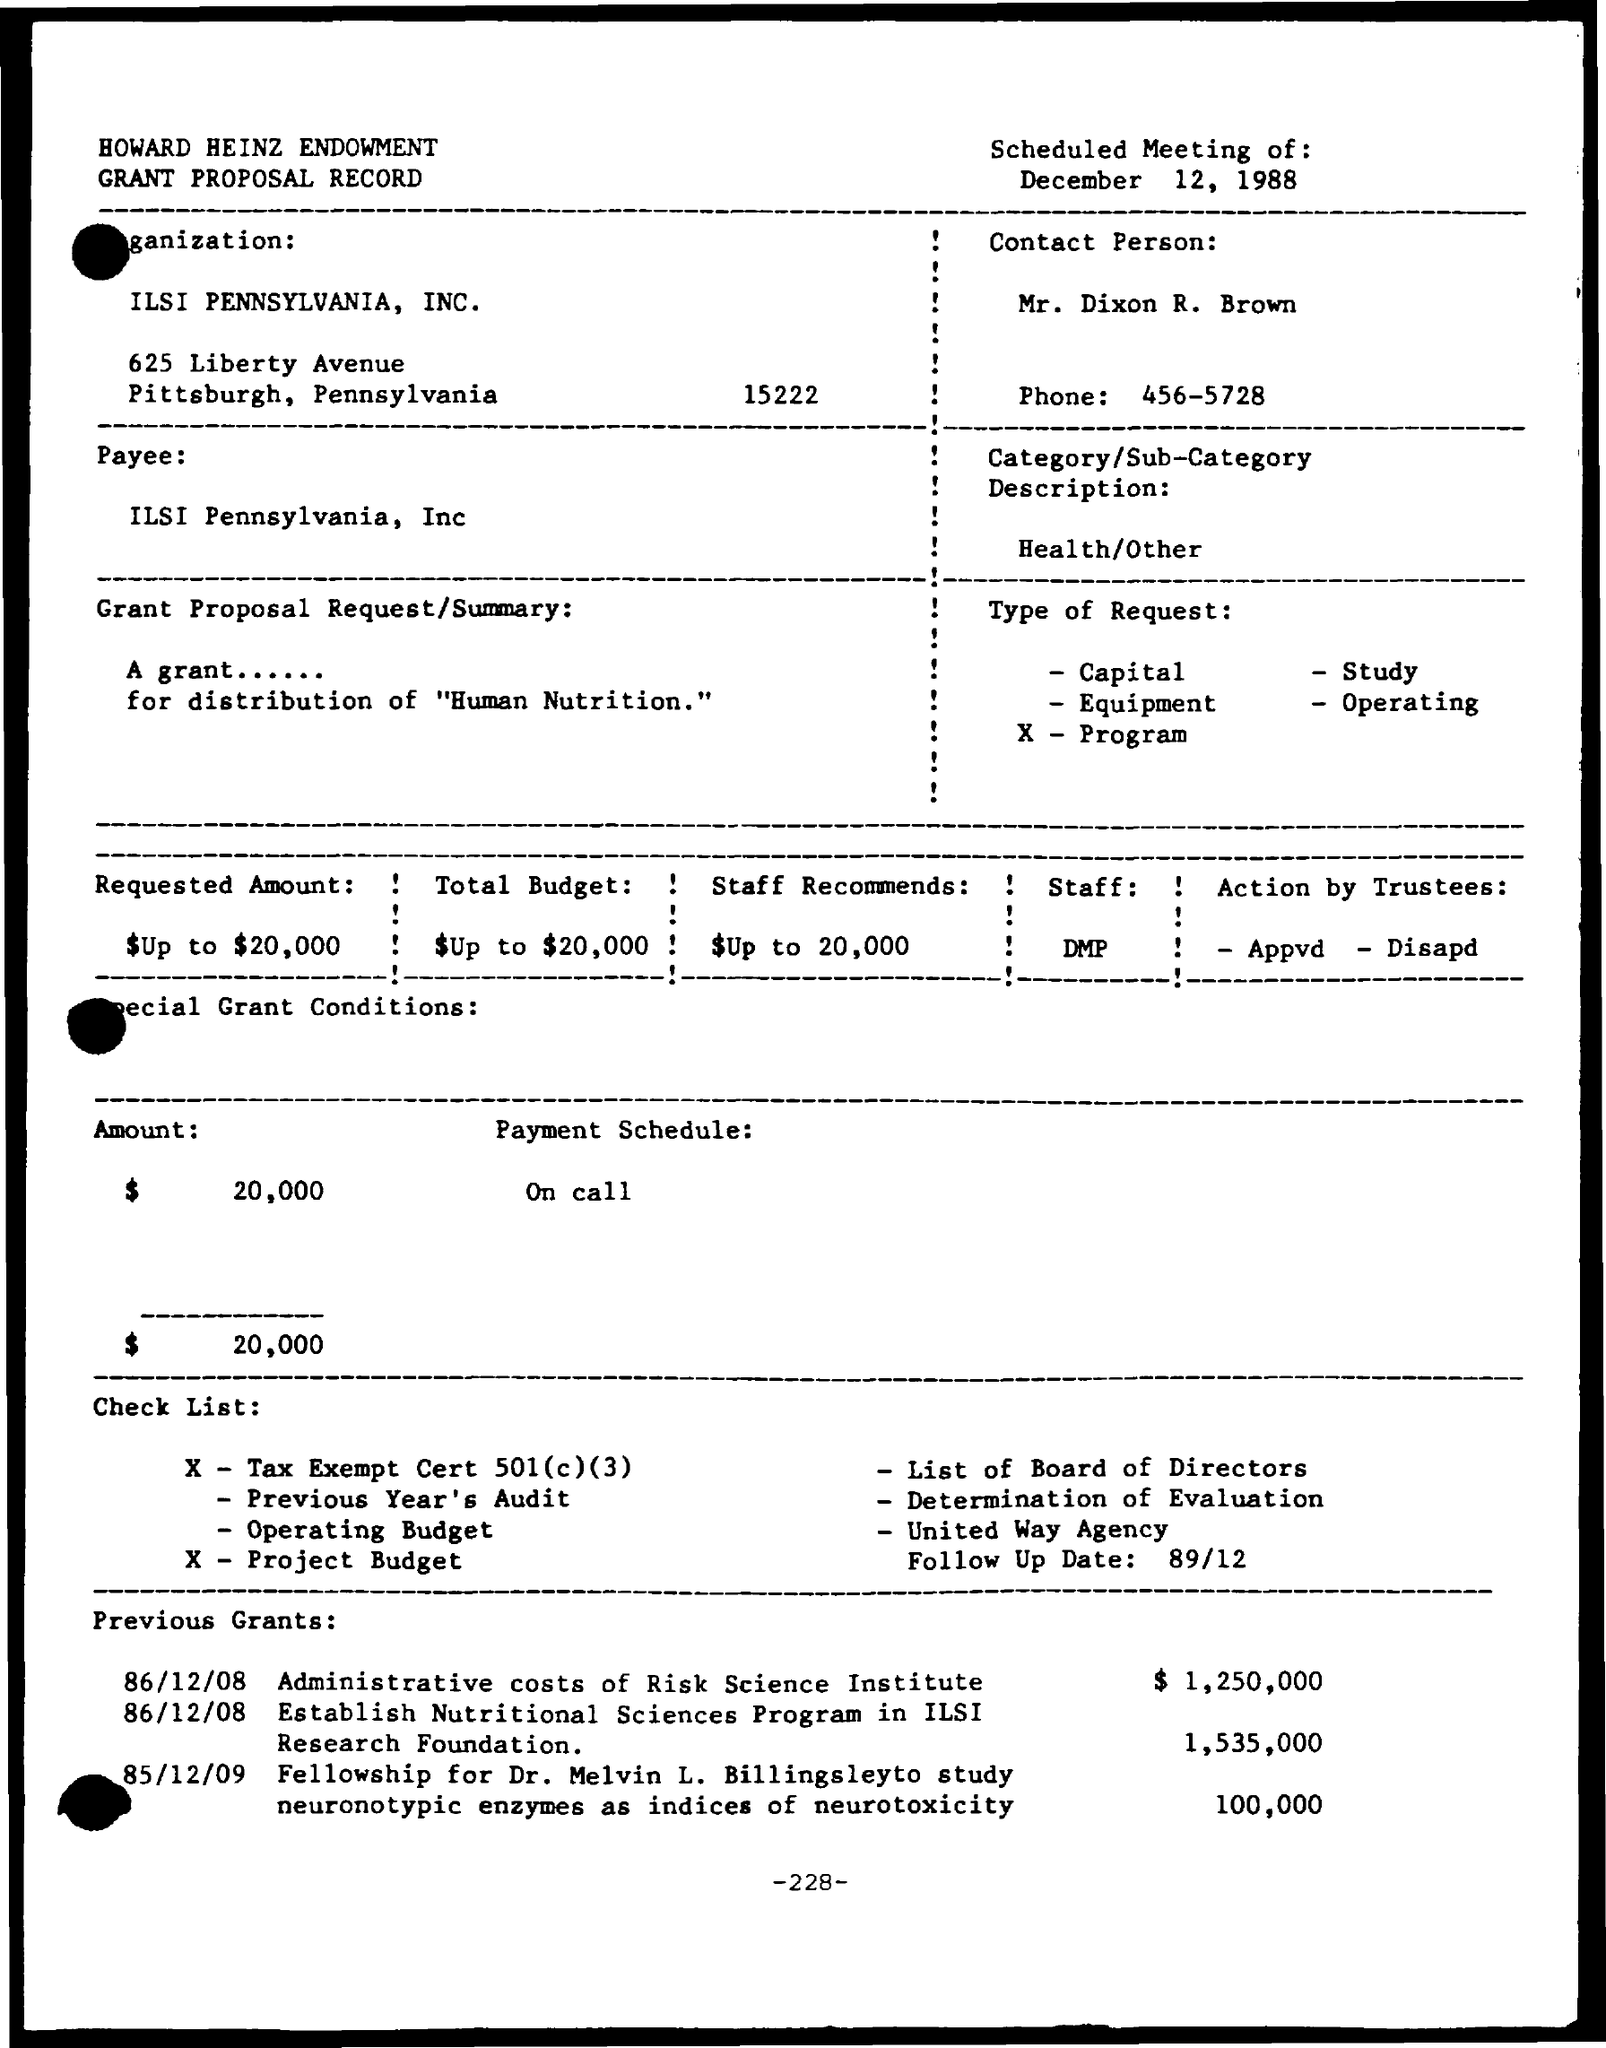When is the meeting?
Offer a very short reply. December 12, 1988. Which is the Organization?
Provide a short and direct response. ILSI Pennsylvania, INC. Who is the Contact Person?
Provide a short and direct response. MR. DIXON R. BROWN. Who is the Payee?
Your answer should be compact. ILSI PENNSYLVANIA, INC. What is the Category/Sub-Category Description?
Give a very brief answer. Health/Other. What is the Amount?
Your answer should be compact. $20,000. What is the Payment Schedule?
Your answer should be compact. ON CALL. What is the Administrative costs of Risk Science Institute?
Provide a succinct answer. $1,250,000. 